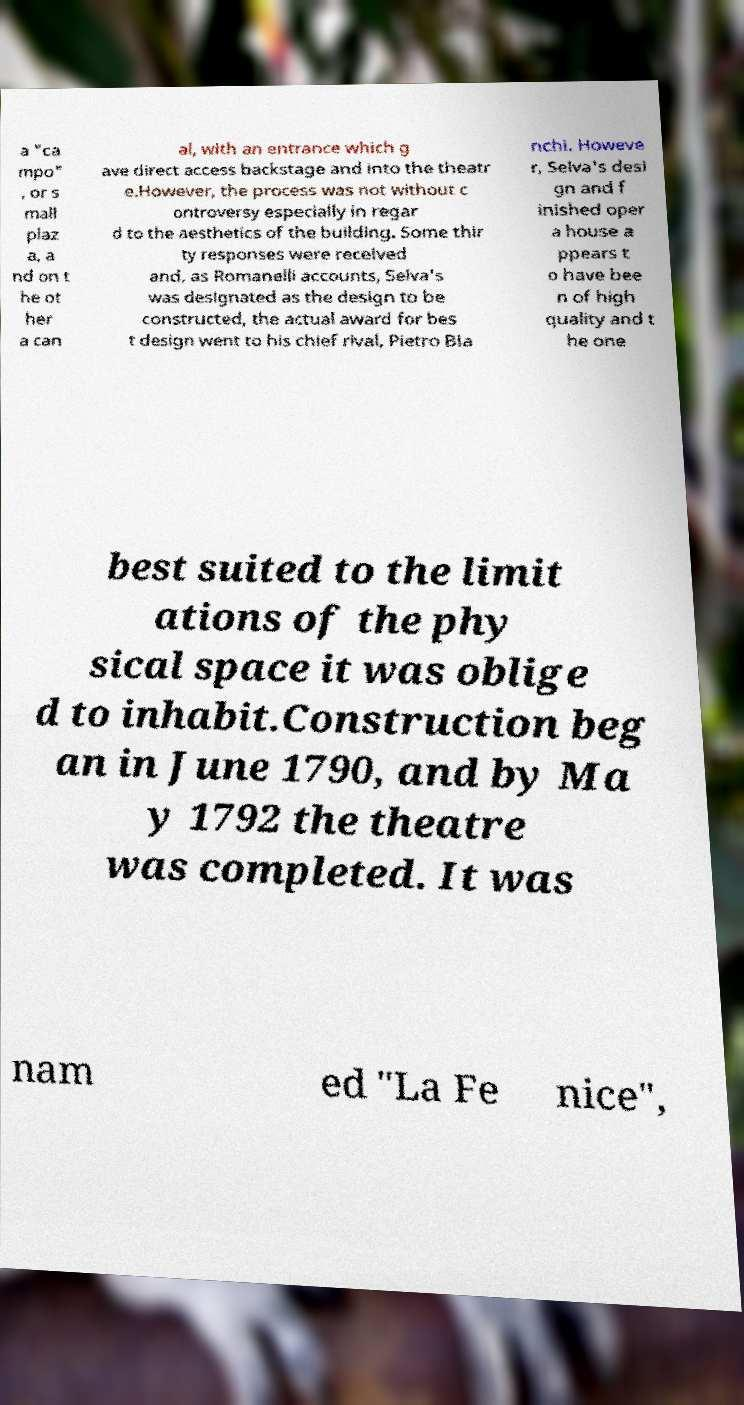Can you accurately transcribe the text from the provided image for me? a "ca mpo" , or s mall plaz a, a nd on t he ot her a can al, with an entrance which g ave direct access backstage and into the theatr e.However, the process was not without c ontroversy especially in regar d to the aesthetics of the building. Some thir ty responses were received and, as Romanelli accounts, Selva's was designated as the design to be constructed, the actual award for bes t design went to his chief rival, Pietro Bia nchi. Howeve r, Selva's desi gn and f inished oper a house a ppears t o have bee n of high quality and t he one best suited to the limit ations of the phy sical space it was oblige d to inhabit.Construction beg an in June 1790, and by Ma y 1792 the theatre was completed. It was nam ed "La Fe nice", 